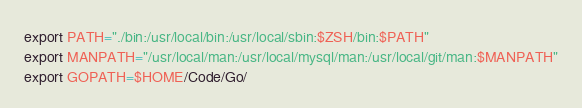Convert code to text. <code><loc_0><loc_0><loc_500><loc_500><_Bash_>export PATH="./bin:/usr/local/bin:/usr/local/sbin:$ZSH/bin:$PATH"
export MANPATH="/usr/local/man:/usr/local/mysql/man:/usr/local/git/man:$MANPATH"
export GOPATH=$HOME/Code/Go/
</code> 